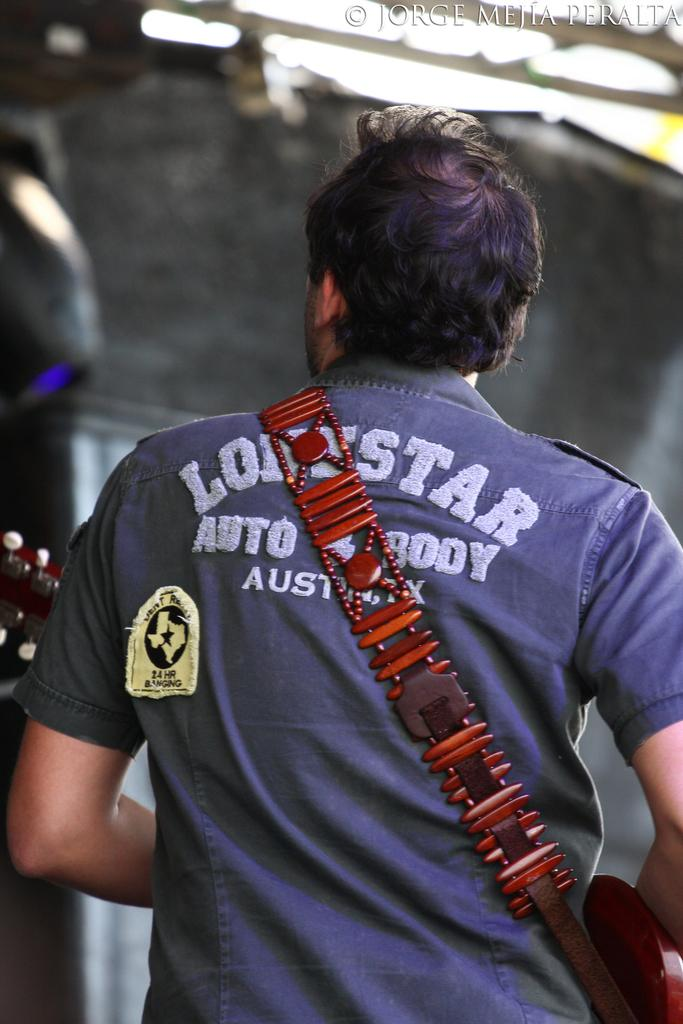<image>
Render a clear and concise summary of the photo. A man is walking with a lonestar shirt 